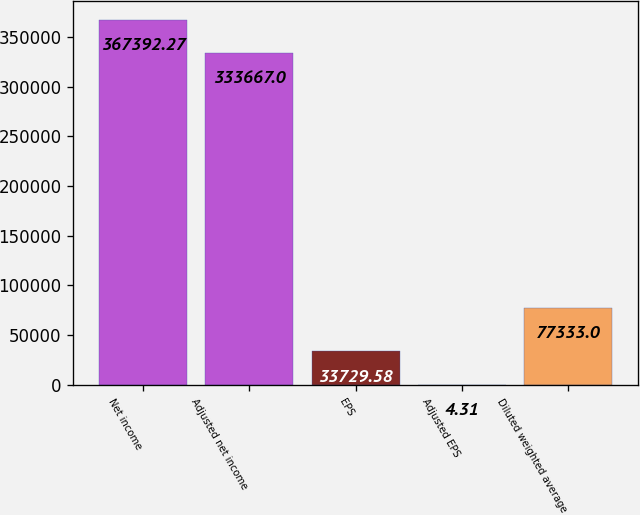Convert chart. <chart><loc_0><loc_0><loc_500><loc_500><bar_chart><fcel>Net income<fcel>Adjusted net income<fcel>EPS<fcel>Adjusted EPS<fcel>Diluted weighted average<nl><fcel>367392<fcel>333667<fcel>33729.6<fcel>4.31<fcel>77333<nl></chart> 